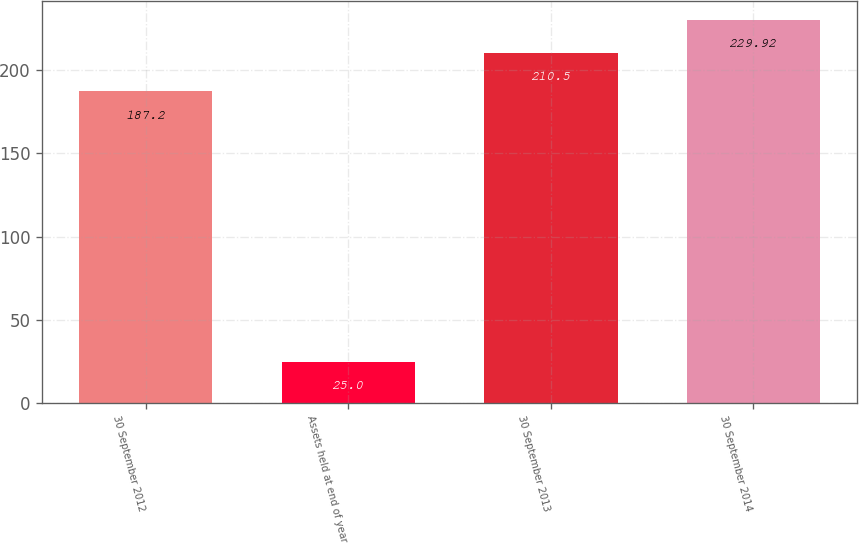Convert chart to OTSL. <chart><loc_0><loc_0><loc_500><loc_500><bar_chart><fcel>30 September 2012<fcel>Assets held at end of year<fcel>30 September 2013<fcel>30 September 2014<nl><fcel>187.2<fcel>25<fcel>210.5<fcel>229.92<nl></chart> 